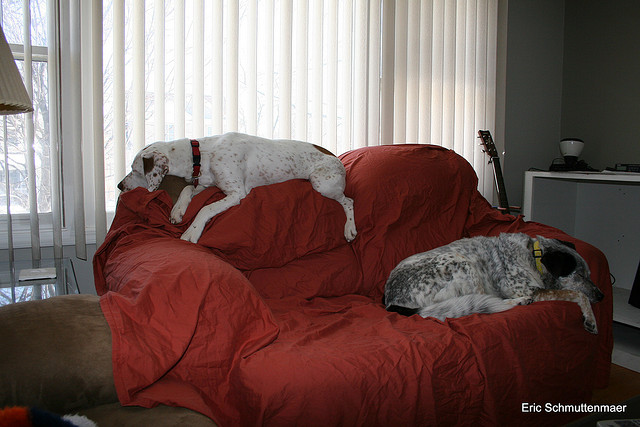<image>Which animal is wearing bows? It's ambiguous which animal is wearing bows. It could be a dog or none of them. Which animal is wearing bows? It is ambiguous which animal is wearing bows. It can be seen that both the dog and neither animal are wearing bows. 